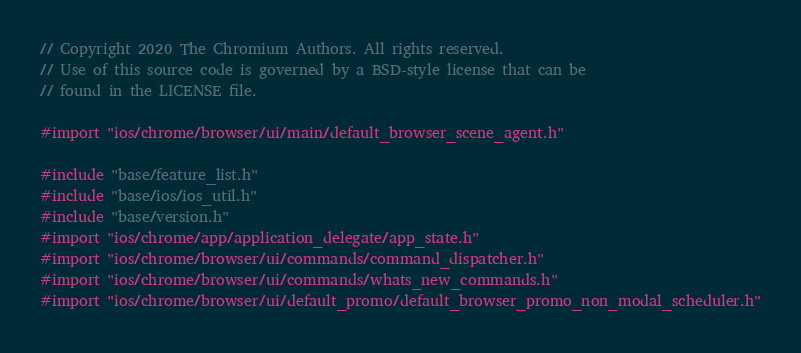<code> <loc_0><loc_0><loc_500><loc_500><_ObjectiveC_>// Copyright 2020 The Chromium Authors. All rights reserved.
// Use of this source code is governed by a BSD-style license that can be
// found in the LICENSE file.

#import "ios/chrome/browser/ui/main/default_browser_scene_agent.h"

#include "base/feature_list.h"
#include "base/ios/ios_util.h"
#include "base/version.h"
#import "ios/chrome/app/application_delegate/app_state.h"
#import "ios/chrome/browser/ui/commands/command_dispatcher.h"
#import "ios/chrome/browser/ui/commands/whats_new_commands.h"
#import "ios/chrome/browser/ui/default_promo/default_browser_promo_non_modal_scheduler.h"</code> 